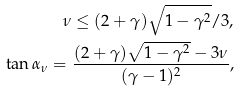Convert formula to latex. <formula><loc_0><loc_0><loc_500><loc_500>\nu \leq ( 2 + \gamma ) \sqrt { 1 - \gamma ^ { 2 } } / 3 , \\ \tan \alpha _ { \nu } = \frac { ( 2 + \gamma ) \sqrt { 1 - \gamma ^ { 2 } } - 3 \nu } { ( \gamma - 1 ) ^ { 2 } } ,</formula> 